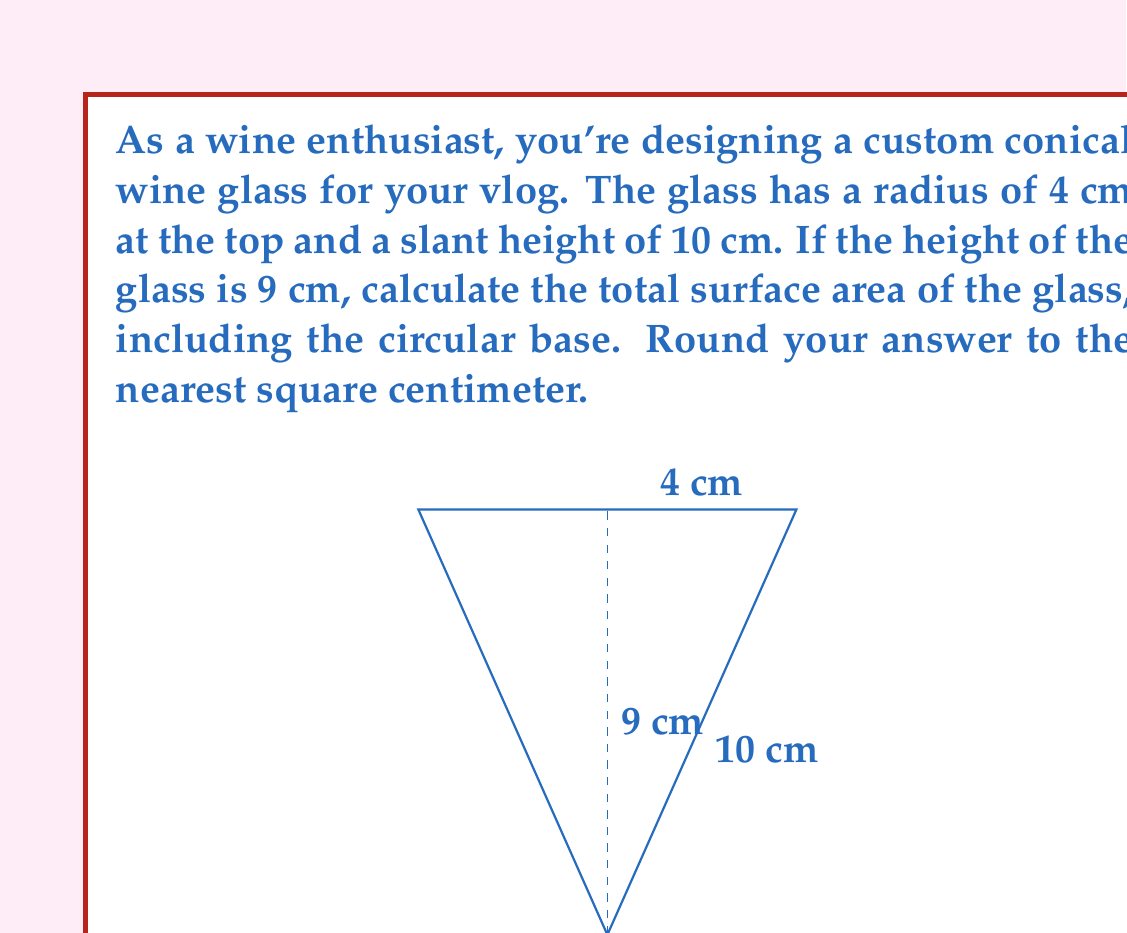Teach me how to tackle this problem. Let's approach this step-by-step:

1) First, we need to find the radius of the base. We can do this using the Pythagorean theorem:

   $r^2 + h^2 = s^2$
   
   Where $r$ is the radius of the base, $h$ is the height, and $s$ is the slant height.

2) We know $h = 9$ cm and $s = 10$ cm. Let's substitute:

   $r^2 + 9^2 = 10^2$
   $r^2 + 81 = 100$
   $r^2 = 19$
   $r = \sqrt{19} \approx 4.36$ cm

3) Now we can calculate the surface area. The total surface area consists of:
   - The lateral surface area of the cone (side)
   - The area of the circular base
   - The area of the circular top

4) Lateral surface area of a cone: $A_l = \pi r_1 s$
   Where $r_1$ is the radius of the base and $s$ is the slant height.
   
   $A_l = \pi \cdot 4.36 \cdot 10 \approx 137.08$ cm²

5) Area of the circular base: $A_b = \pi r_1^2$
   
   $A_b = \pi \cdot 4.36^2 \approx 59.78$ cm²

6) Area of the circular top: $A_t = \pi r_2^2$
   Where $r_2$ is the radius of the top (given as 4 cm)
   
   $A_t = \pi \cdot 4^2 = 16\pi \approx 50.27$ cm²

7) Total surface area: $A_{total} = A_l + A_b + A_t$
   
   $A_{total} = 137.08 + 59.78 + 50.27 = 247.13$ cm²

8) Rounding to the nearest square centimeter:

   $A_{total} \approx 247$ cm²
Answer: 247 cm² 